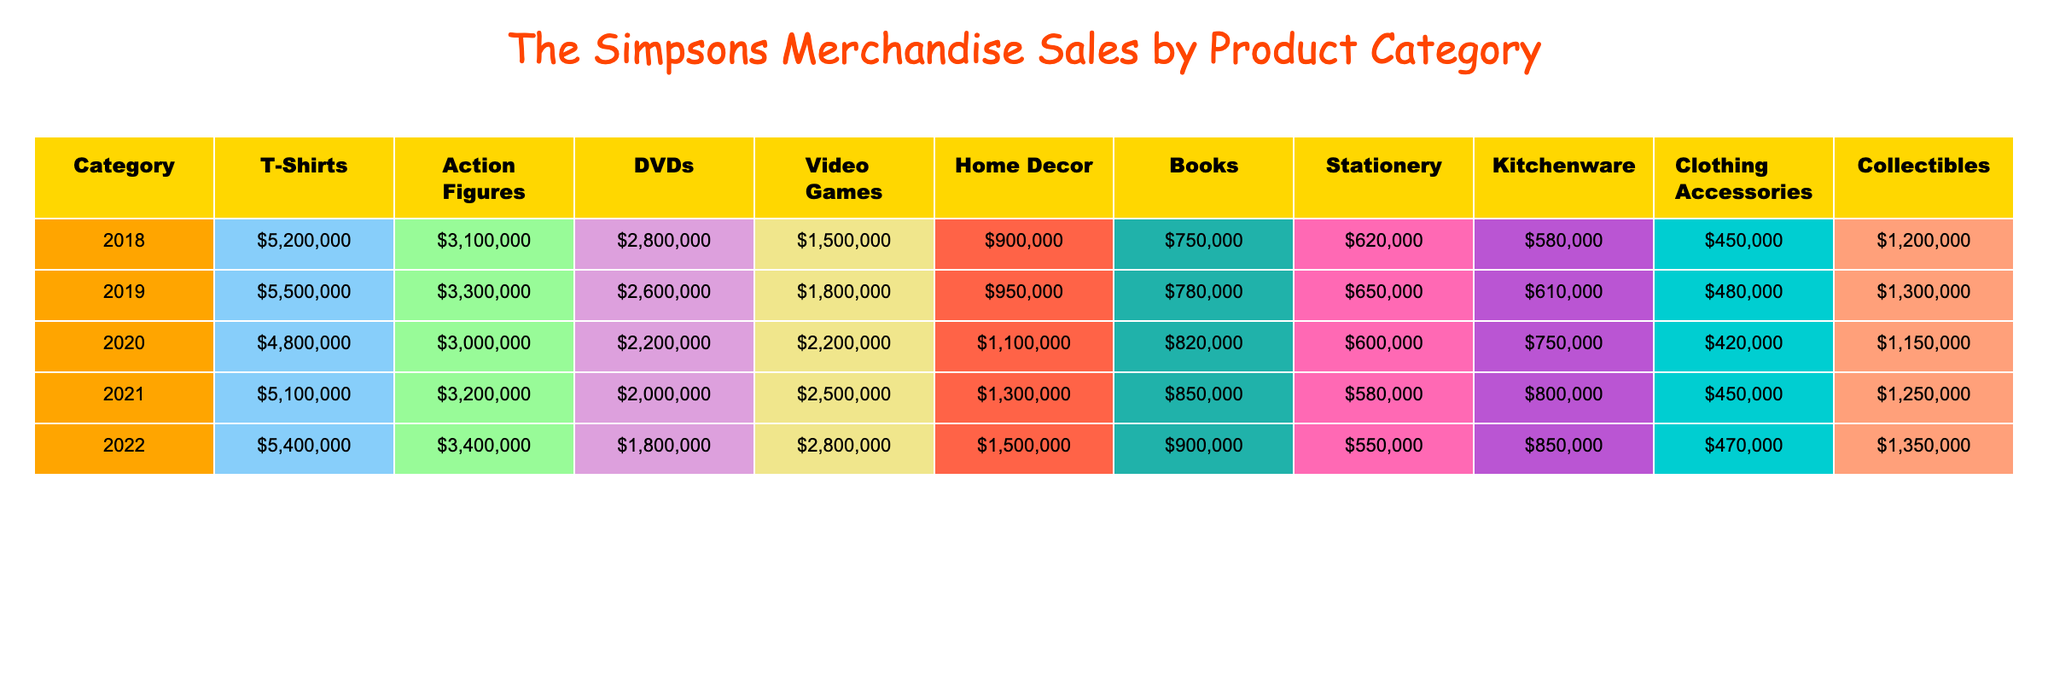What was the highest sales figure for T-Shirts, and in which year did it occur? The highest sales figure for T-Shirts is 5,500,000, which occurred in 2019.
Answer: 5,500,000 in 2019 Which year saw the lowest sales in the Action Figures category? The lowest sales in the Action Figures category are 3,000,000, which occurred in 2020.
Answer: 2020 In which category did sales increase every year? The category that increased sales every year is 'Clothing Accessories,' which shows a progression from 450,000 in 2018 to 480,000 in 2019.
Answer: Clothing Accessories What was the total revenue from Video Games in the years 2018 and 2019 combined? Adding the sales figures from 2018 (1,500,000) and 2019 (1,800,000) gives a total of 3,300,000.
Answer: 3,300,000 Which category had the highest sales in 2022? In 2022, the category with the highest sales was Action Figures, totaling 3,400,000.
Answer: Action Figures with 3,400,000 What is the average sales figure for DVDs over the five years? To find the average sales for DVDs, sum 2,800,000 + 2,600,000 + 2,200,000 + 2,000,000 + 1,800,000 = 11,600,000, then divide by 5 to get 2,320,000.
Answer: 2,320,000 Did the sales for Kitchenware ever exceed 1,000,000? No, the sales for Kitchenware did not exceed 1,000,000 in any year. The highest was 850,000 in 2022.
Answer: No In 2021, which category had sales figures that were less than both the T-Shirts and DVDs categories? T-Shirts sales in 2021 were 5,100,000 and DVDs were 2,000,000. The categories with lower sales are Home Decor (1,300,000) and Stationery (580,000).
Answer: Home Decor and Stationery Which product category's sales had the greatest fluctuation over the five years? The product category with the greatest fluctuation appears to be DVDs, with a high of 2,800,000 in 2018 and a low of 1,800,000 in 2022.
Answer: DVDs What was the percentage increase in sales from T-Shirts in 2018 to 2022? The sales increased from 5,200,000 in 2018 to 5,400,000 in 2022. The percentage increase is calculated as ((5,400,000 - 5,200,000) / 5,200,000) * 100, which equals approximately 3.85%.
Answer: Approximately 3.85% 